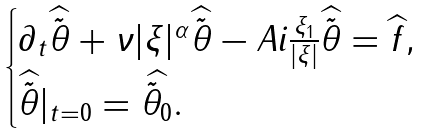Convert formula to latex. <formula><loc_0><loc_0><loc_500><loc_500>\begin{cases} \partial _ { t } \widehat { \tilde { \theta } } + \nu | \xi | ^ { \alpha } \widehat { \tilde { \theta } } - A i \frac { \xi _ { 1 } } { | \xi | } \widehat { \tilde { \theta } } = \widehat { f } , \\ \widehat { \tilde { \theta } } | _ { t = 0 } = \widehat { \tilde { \theta } _ { 0 } } . \end{cases}</formula> 